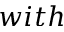Convert formula to latex. <formula><loc_0><loc_0><loc_500><loc_500>w i t h</formula> 